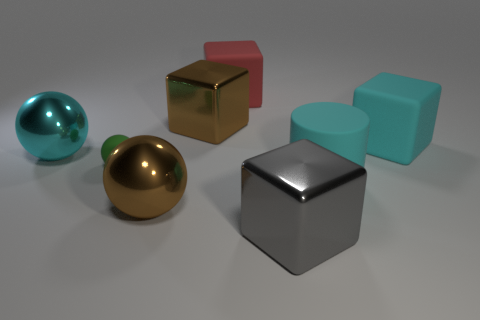Subtract 1 blocks. How many blocks are left? 3 Add 1 large cyan rubber cylinders. How many objects exist? 9 Subtract all balls. How many objects are left? 5 Subtract all tiny purple metallic objects. Subtract all big gray metal blocks. How many objects are left? 7 Add 6 big rubber blocks. How many big rubber blocks are left? 8 Add 6 cyan metal spheres. How many cyan metal spheres exist? 7 Subtract 1 green spheres. How many objects are left? 7 